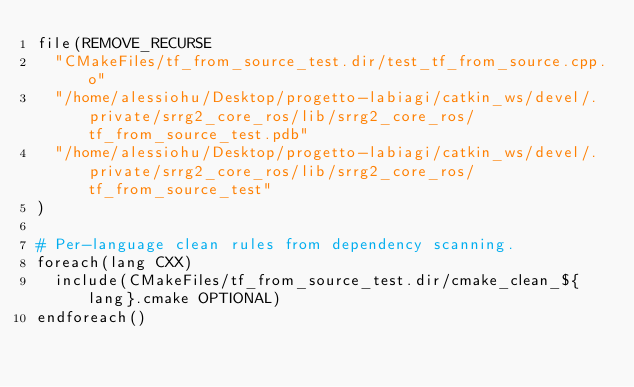<code> <loc_0><loc_0><loc_500><loc_500><_CMake_>file(REMOVE_RECURSE
  "CMakeFiles/tf_from_source_test.dir/test_tf_from_source.cpp.o"
  "/home/alessiohu/Desktop/progetto-labiagi/catkin_ws/devel/.private/srrg2_core_ros/lib/srrg2_core_ros/tf_from_source_test.pdb"
  "/home/alessiohu/Desktop/progetto-labiagi/catkin_ws/devel/.private/srrg2_core_ros/lib/srrg2_core_ros/tf_from_source_test"
)

# Per-language clean rules from dependency scanning.
foreach(lang CXX)
  include(CMakeFiles/tf_from_source_test.dir/cmake_clean_${lang}.cmake OPTIONAL)
endforeach()
</code> 